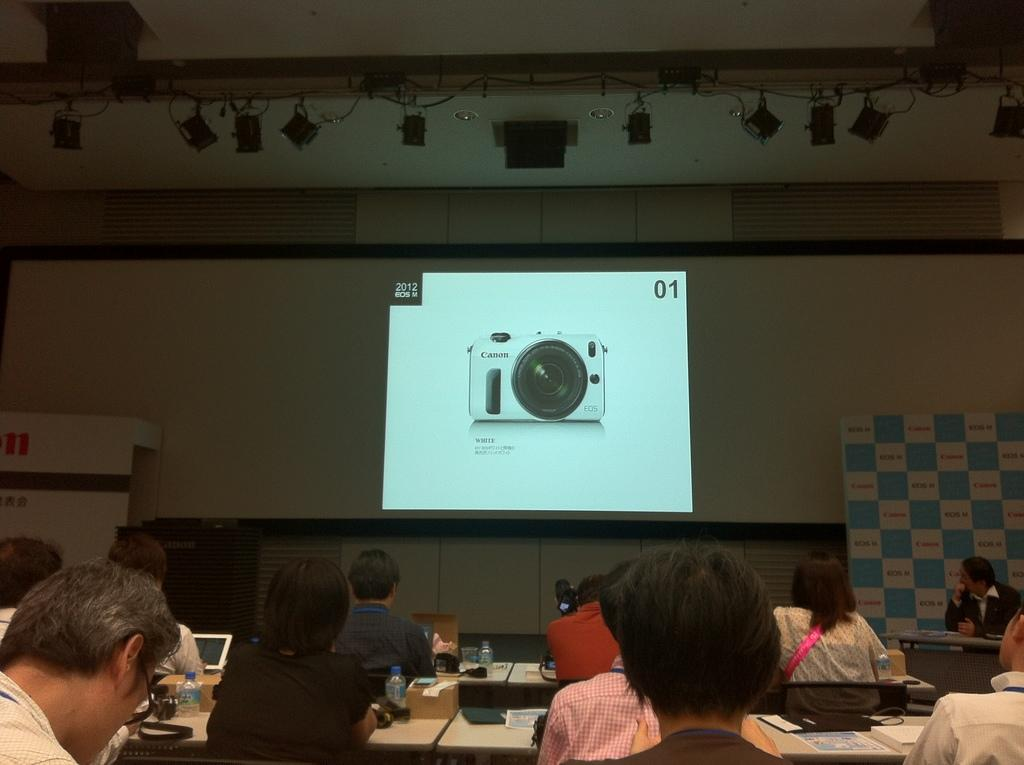Who or what is located at the bottom of the image? There is a group of people at the bottom of the image. What items can be seen on the tables in the image? There are water bottles on tables in the image. What is the main feature in the middle of the image? There is a projector screen in the middle of the image. What type of wave can be seen crashing on the shore in the image? There is no wave or shore present in the image; it features a group of people, water bottles, and a projector screen. How many train cars are visible in the image? There are no train cars present in the image. 